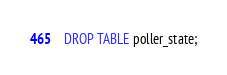<code> <loc_0><loc_0><loc_500><loc_500><_SQL_>DROP TABLE poller_state;
</code> 